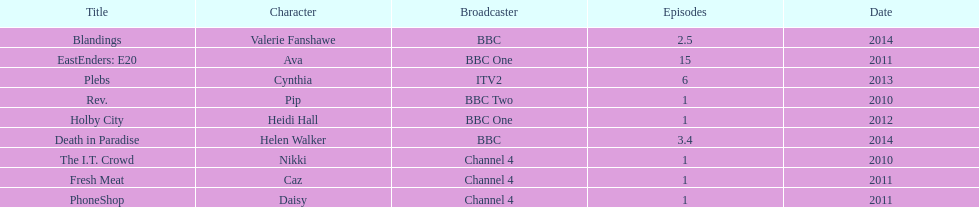How many titles have at least 5 episodes? 2. 